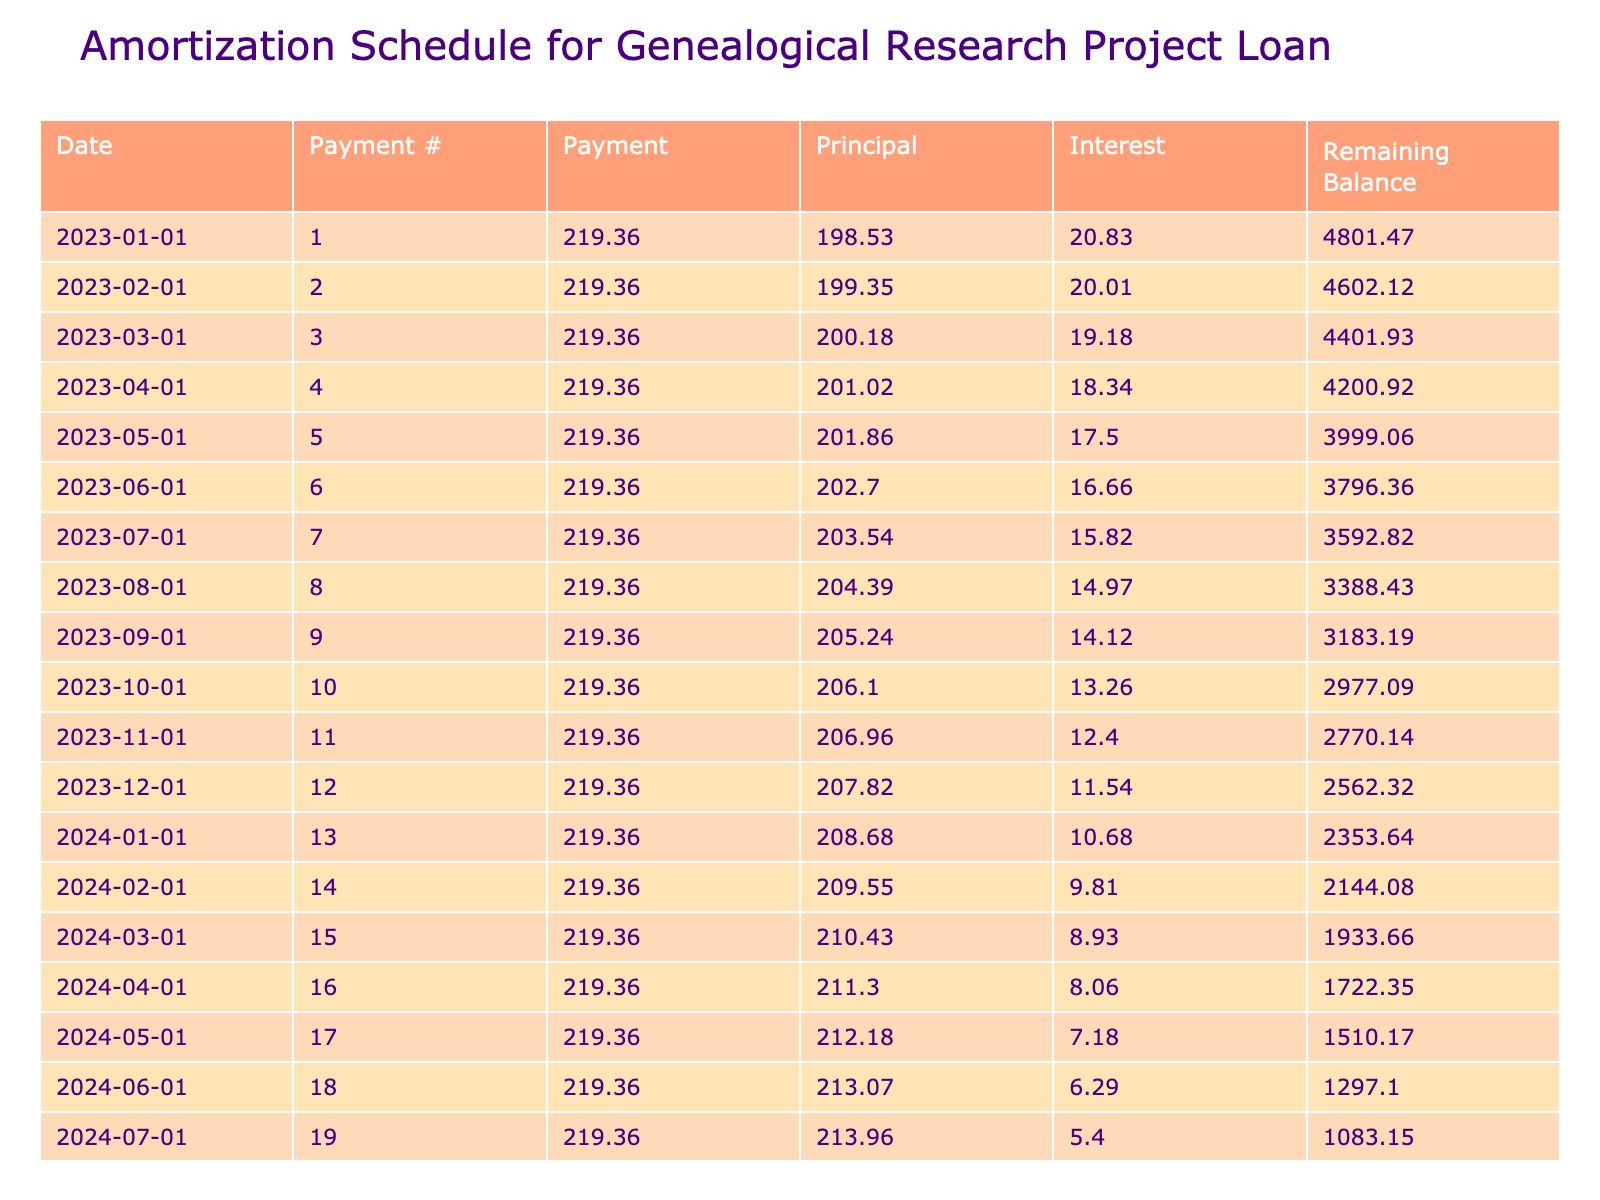What is the total amount to be paid over the term of the loan? The total payment value listed in the table is taken directly from there, which is 5264.68.
Answer: 5264.68 What is the monthly payment amount? The monthly payment is stated in the table, and the value is 219.36.
Answer: 219.36 How much total interest will be paid by the end of the loan? The total interest calculated over the term of the loan is 264.68, as shown in the table.
Answer: 264.68 Is the principal of the last payment greater than the interest of the last payment? The last payment's principal is calculated directly from the schedule, and the remaining balance is 0, while its interest component for the final month is also provided. Since the principal is greater than zero and the interest is zero, this statement is true.
Answer: Yes What is the remaining balance after the first payment? The first payment details show that the initial balance is 5000. After the first payment, which consists of the monthly payment minus the interest (which is 20.83), the remaining balance will be 5000 - (219.36 - 20.83) = 4801.47.
Answer: 4801.47 How does the principal amount change over the course of the loan? To see how the principal amount changes, we observe the principal column throughout the payments. The first month has a principal of 198.53, and each subsequent month typically shows an increase in the principal as the balance decreases, indicating a trend toward higher principal contributions over time.
Answer: Increases over time What is the average monthly payment over the loan term? Since the monthly payment is consistent throughout the loan term, the average is simply equal to the monthly payment itself, which is 219.36.
Answer: 219.36 Did the total payment exceed the loan amount? By comparing the total payment of 5264.68 with the original loan amount of 5000, it is clear that the total payment does exceed the loan amount, confirming a yes answer.
Answer: Yes What was the interest paid in the first month? The interest for the first month is calculated by applying the monthly interest rate to the loan amount. The value is found to be 20.83, which is listed in the first month's interest column of the schedule.
Answer: 20.83 What will be the remaining balance after three months? The remaining balance after three months can be calculated sequentially from the balance at the end of each prior month. After three months, the remaining balance comes to 4651.23, reflecting the cumulative payments and interest reductions.
Answer: 4651.23 